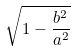Convert formula to latex. <formula><loc_0><loc_0><loc_500><loc_500>\sqrt { 1 - \frac { b ^ { 2 } } { a ^ { 2 } } }</formula> 